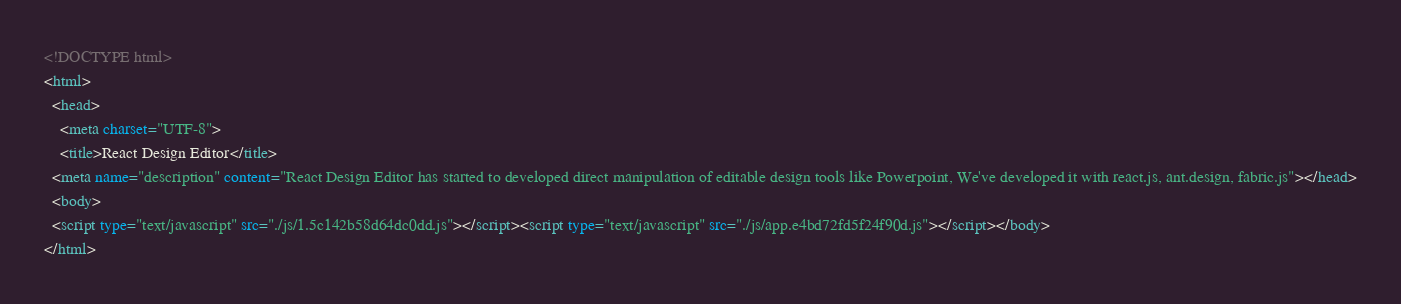Convert code to text. <code><loc_0><loc_0><loc_500><loc_500><_HTML_><!DOCTYPE html>
<html>
  <head>
    <meta charset="UTF-8">
    <title>React Design Editor</title>
  <meta name="description" content="React Design Editor has started to developed direct manipulation of editable design tools like Powerpoint, We've developed it with react.js, ant.design, fabric.js"></head>
  <body>
  <script type="text/javascript" src="./js/1.5c142b58d64dc0dd.js"></script><script type="text/javascript" src="./js/app.e4bd72fd5f24f90d.js"></script></body>
</html></code> 